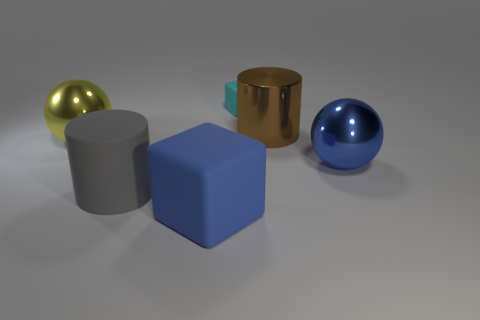What could be the function of these objects if they were not merely 3D models? If they were not simply 3D models, these objects could represent a variety of real-world items. The shiny yellow ball might be a decorative ornament, the brown cylinder could serve as a sleek modern vase, the blue object may be interpreted as a contemporary paperweight, and the metallic teal cube could be an avant-garde piece of art or a unique geometric sculpture. 